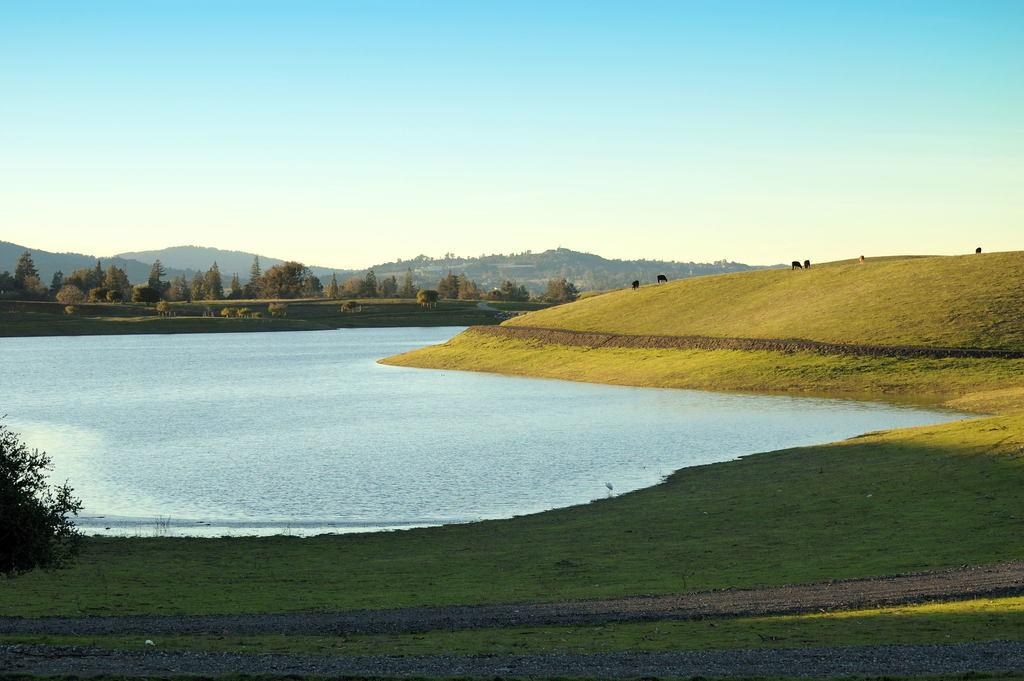What are the animals in the image doing? The animals are grazing in the grass. What type of vegetation can be seen in the image? There are trees and plants in the image. What can be seen in the background of the image? There are mountains in the image. What is the condition of the sky in the image? The sky is visible in the image. What type of needle is being used by the animals to sew their clothes in the image? There are no animals sewing clothes or using needles in the image. 